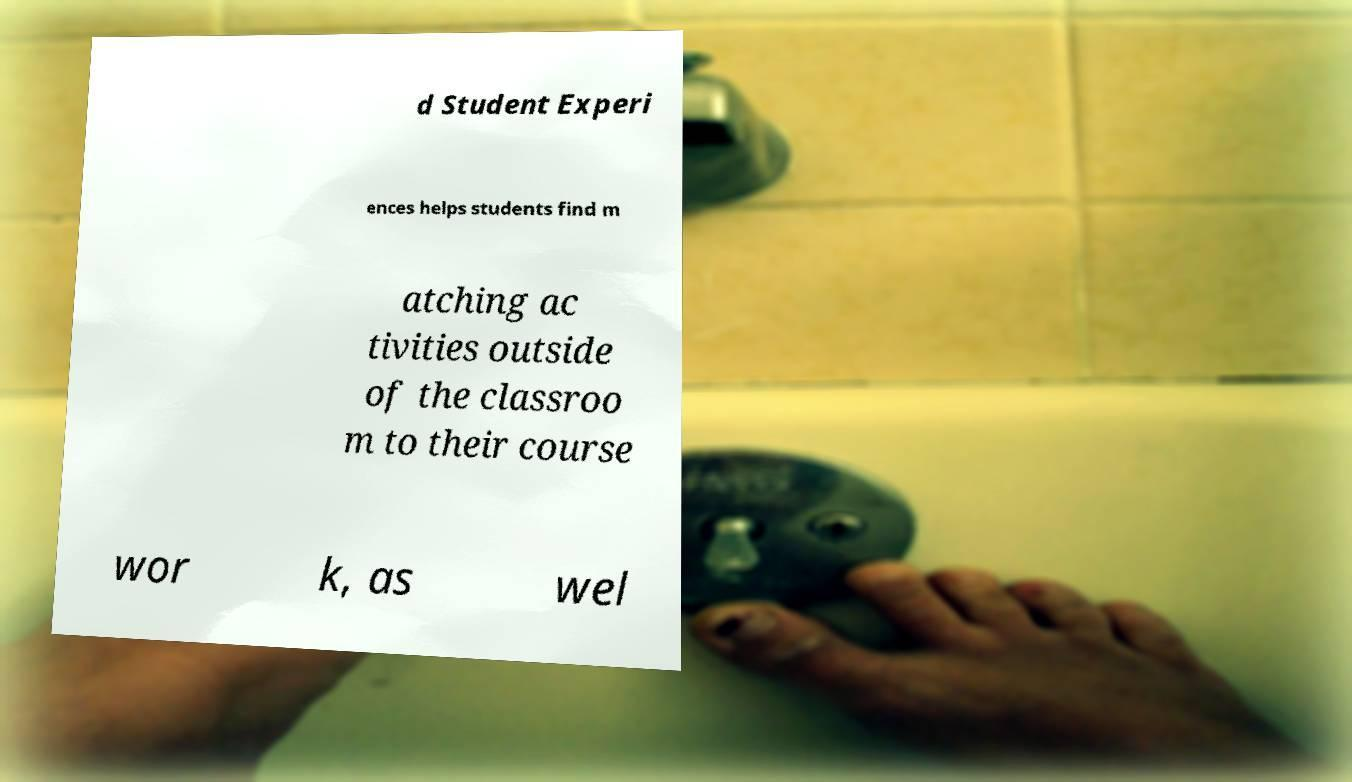Can you read and provide the text displayed in the image?This photo seems to have some interesting text. Can you extract and type it out for me? d Student Experi ences helps students find m atching ac tivities outside of the classroo m to their course wor k, as wel 